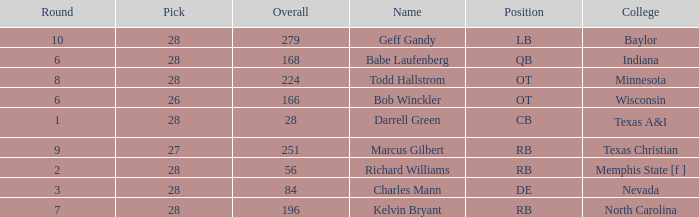What is the lowest round of the position de player with an overall less than 84? None. 